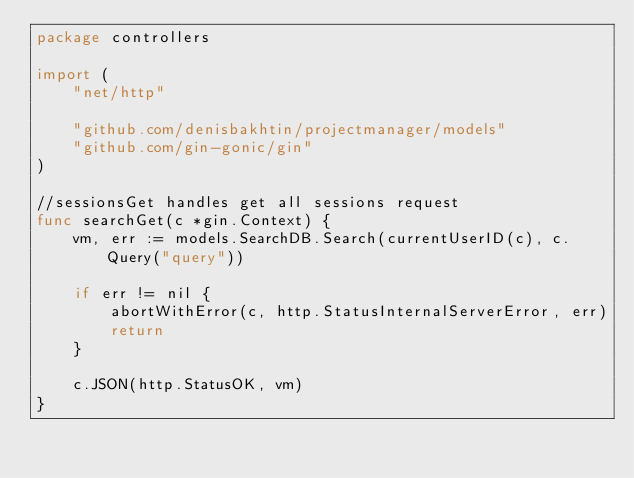<code> <loc_0><loc_0><loc_500><loc_500><_Go_>package controllers

import (
	"net/http"

	"github.com/denisbakhtin/projectmanager/models"
	"github.com/gin-gonic/gin"
)

//sessionsGet handles get all sessions request
func searchGet(c *gin.Context) {
	vm, err := models.SearchDB.Search(currentUserID(c), c.Query("query"))

	if err != nil {
		abortWithError(c, http.StatusInternalServerError, err)
		return
	}

	c.JSON(http.StatusOK, vm)
}
</code> 